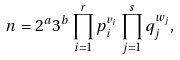<formula> <loc_0><loc_0><loc_500><loc_500>n = 2 ^ { a } 3 ^ { b } \prod _ { i = 1 } ^ { r } p _ { i } ^ { v _ { i } } \prod _ { j = 1 } ^ { s } q _ { j } ^ { w _ { j } } ,</formula> 